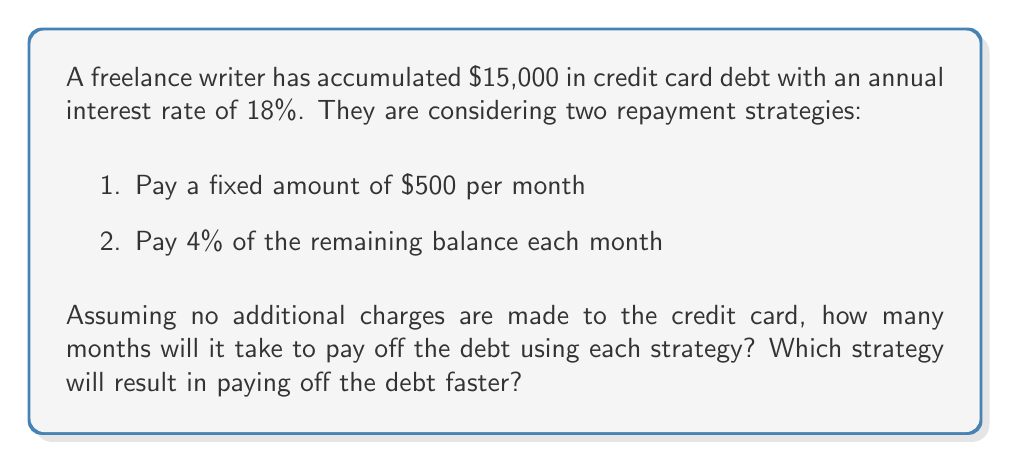Teach me how to tackle this problem. Let's analyze each strategy separately:

1. Fixed payment of $500 per month:

We can use the formula for the time to pay off a loan with fixed payments:

$$ T = \frac{-\ln(1 - \frac{r}{n}(\frac{P}{A}))}{\ln(1 + \frac{r}{n})} $$

Where:
$T$ = number of payments (months)
$r$ = annual interest rate (18% = 0.18)
$n$ = number of compounding periods per year (12 for monthly)
$P$ = principal balance ($15,000)
$A$ = fixed monthly payment ($500)

Plugging in the values:

$$ T = \frac{-\ln(1 - \frac{0.18}{12}(\frac{15000}{500}))}{\ln(1 + \frac{0.18}{12})} $$

$$ T \approx 39.48 $$

Rounding up, it will take 40 months to pay off the debt using this strategy.

2. Pay 4% of the remaining balance each month:

For this strategy, we need to use a recursive formula:

$$ B_{n+1} = B_n(1 + \frac{r}{12}) - 0.04B_n $$

Where $B_n$ is the balance after $n$ months.

We can use a spreadsheet or programming language to calculate this, but here's a simplified approach:

Month 1: $15,000 * (1 + 0.18/12) - 0.04 * 15,000 = 14,475
Month 2: $14,475 * (1 + 0.18/12) - 0.04 * 14,475 = 13,968.56

Continuing this process, we find that it takes approximately 44 months for the balance to reach zero.
Answer: Strategy 1 (fixed $500 payment): 40 months
Strategy 2 (4% of remaining balance): 44 months

The fixed payment strategy will result in paying off the debt faster, taking 40 months compared to 44 months for the percentage-based strategy. 